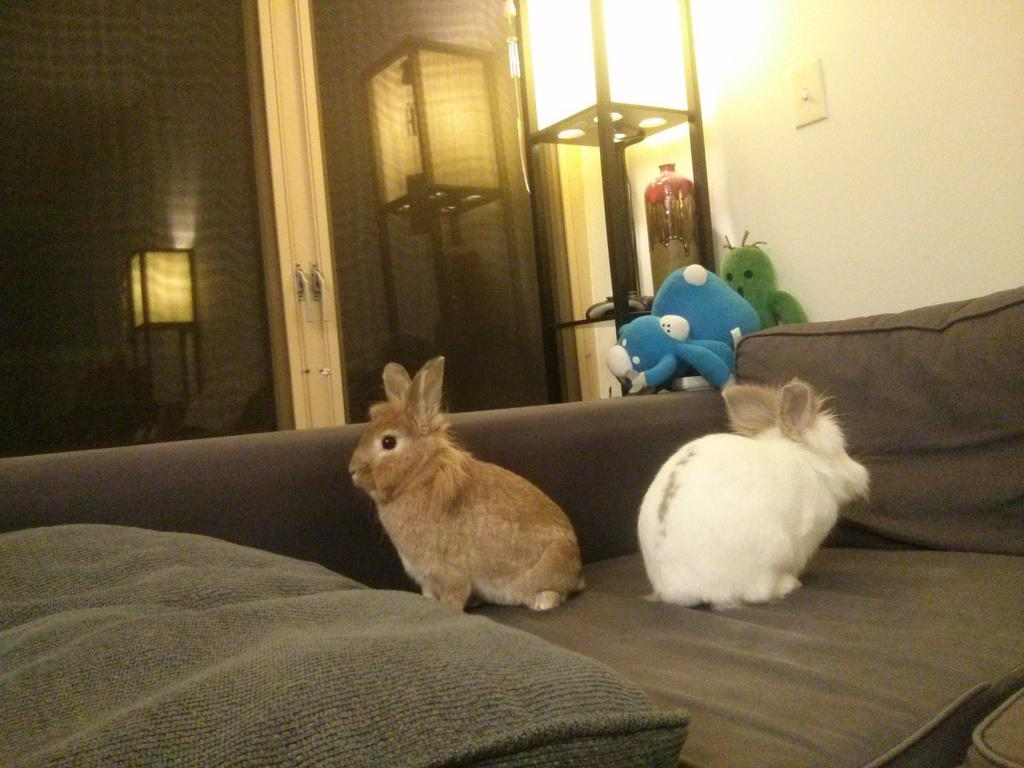What is on the sofa in the image? There are animals on the sofa. What else can be seen near the sofa? There are toys and a vase beside the sofa. Can you describe the lighting in the image? There are lights visible in the image. What type of hat is the animal wearing on the sofa? There is no hat present on the animals in the image. How many balls are visible in the image? There are no balls visible in the image. 